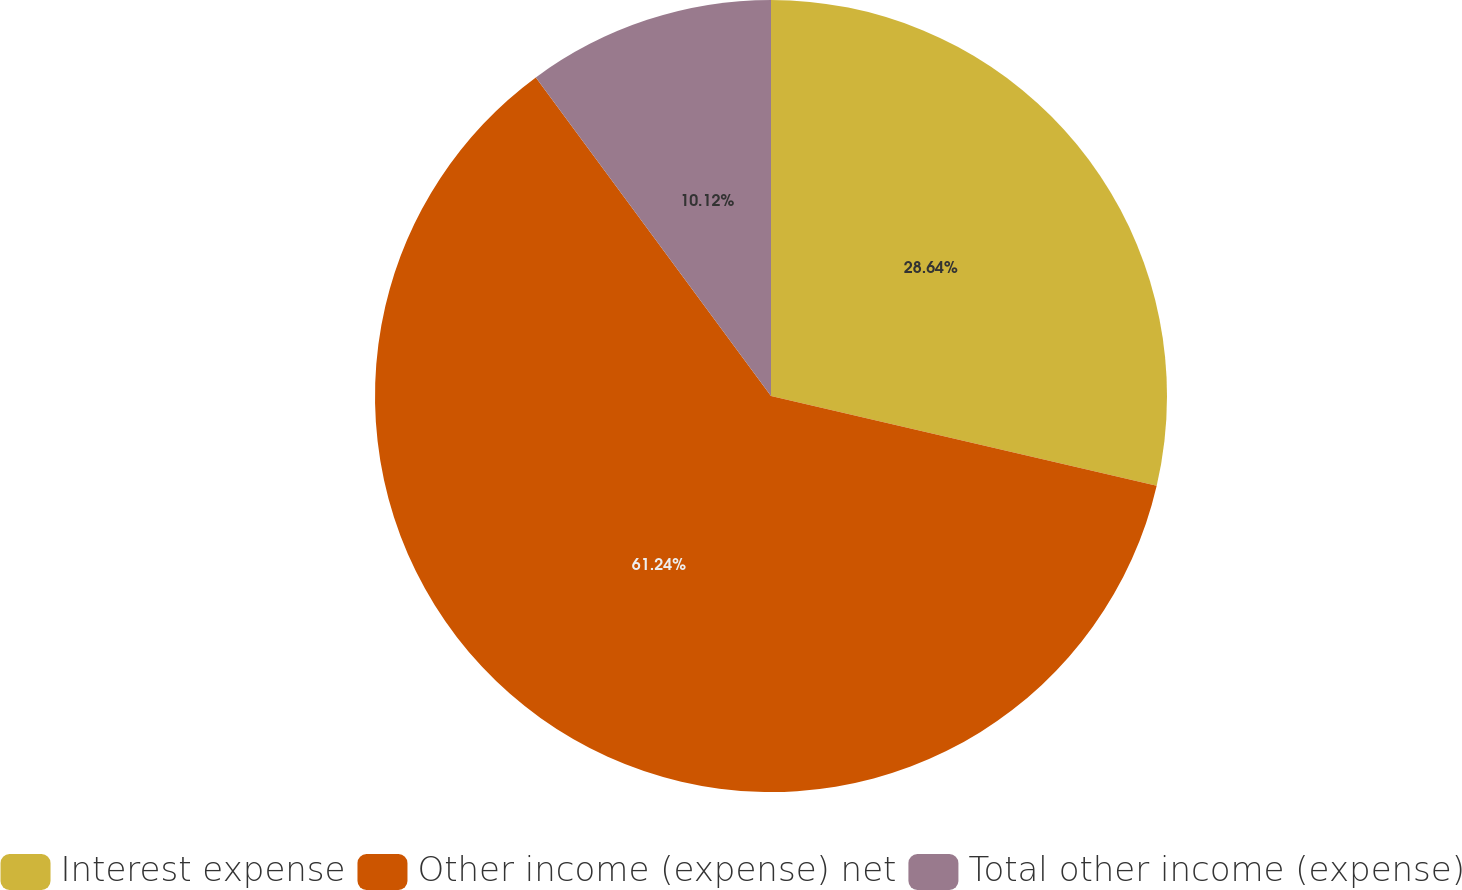Convert chart to OTSL. <chart><loc_0><loc_0><loc_500><loc_500><pie_chart><fcel>Interest expense<fcel>Other income (expense) net<fcel>Total other income (expense)<nl><fcel>28.64%<fcel>61.24%<fcel>10.12%<nl></chart> 